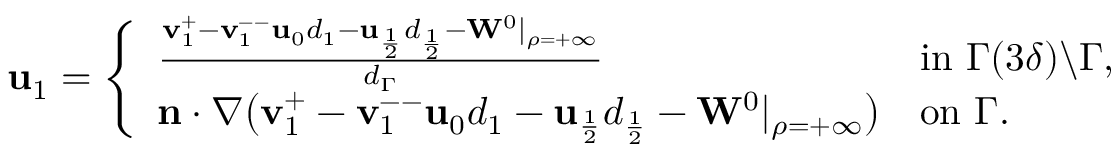<formula> <loc_0><loc_0><loc_500><loc_500>\begin{array} { r } { u _ { 1 } = \left \{ \begin{array} { l l } { \frac { v _ { 1 } ^ { + } - v _ { 1 } ^ { - - } u _ { 0 } d _ { 1 } - u _ { \frac { 1 } { 2 } } d _ { \frac { 1 } { 2 } } - W ^ { 0 } | _ { \rho = + \infty } } { d _ { \Gamma } } } & { i n \Gamma ( 3 \delta ) \ \Gamma , } \\ { n \cdot \nabla \left ( v _ { 1 } ^ { + } - v _ { 1 } ^ { - - } u _ { 0 } d _ { 1 } - u _ { \frac { 1 } { 2 } } d _ { \frac { 1 } { 2 } } - W ^ { 0 } | _ { \rho = + \infty } \right ) } & { o n \Gamma . } \end{array} } \end{array}</formula> 